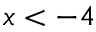Convert formula to latex. <formula><loc_0><loc_0><loc_500><loc_500>x < - 4</formula> 